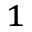Convert formula to latex. <formula><loc_0><loc_0><loc_500><loc_500>_ { 1 }</formula> 